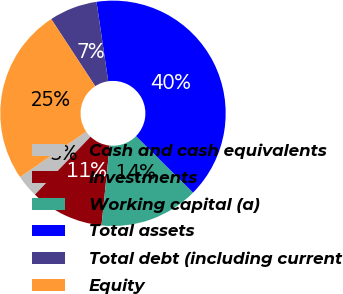Convert chart. <chart><loc_0><loc_0><loc_500><loc_500><pie_chart><fcel>Cash and cash equivalents<fcel>Investments<fcel>Working capital (a)<fcel>Total assets<fcel>Total debt (including current<fcel>Equity<nl><fcel>3.26%<fcel>10.55%<fcel>14.2%<fcel>39.75%<fcel>6.9%<fcel>25.33%<nl></chart> 